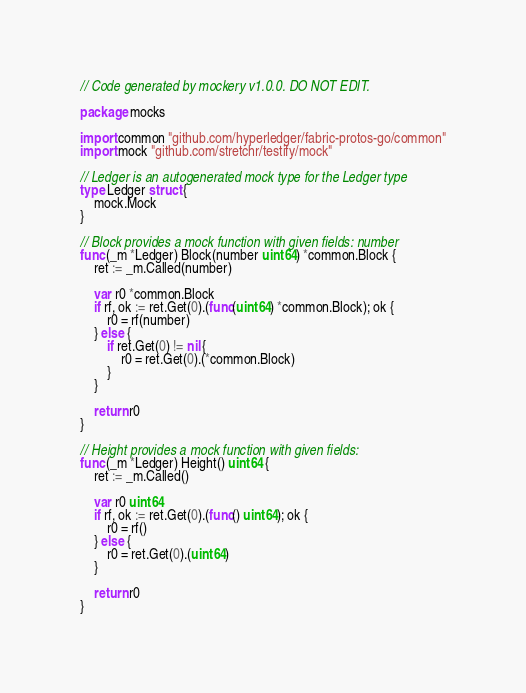Convert code to text. <code><loc_0><loc_0><loc_500><loc_500><_Go_>// Code generated by mockery v1.0.0. DO NOT EDIT.

package mocks

import common "github.com/hyperledger/fabric-protos-go/common"
import mock "github.com/stretchr/testify/mock"

// Ledger is an autogenerated mock type for the Ledger type
type Ledger struct {
	mock.Mock
}

// Block provides a mock function with given fields: number
func (_m *Ledger) Block(number uint64) *common.Block {
	ret := _m.Called(number)

	var r0 *common.Block
	if rf, ok := ret.Get(0).(func(uint64) *common.Block); ok {
		r0 = rf(number)
	} else {
		if ret.Get(0) != nil {
			r0 = ret.Get(0).(*common.Block)
		}
	}

	return r0
}

// Height provides a mock function with given fields:
func (_m *Ledger) Height() uint64 {
	ret := _m.Called()

	var r0 uint64
	if rf, ok := ret.Get(0).(func() uint64); ok {
		r0 = rf()
	} else {
		r0 = ret.Get(0).(uint64)
	}

	return r0
}
</code> 